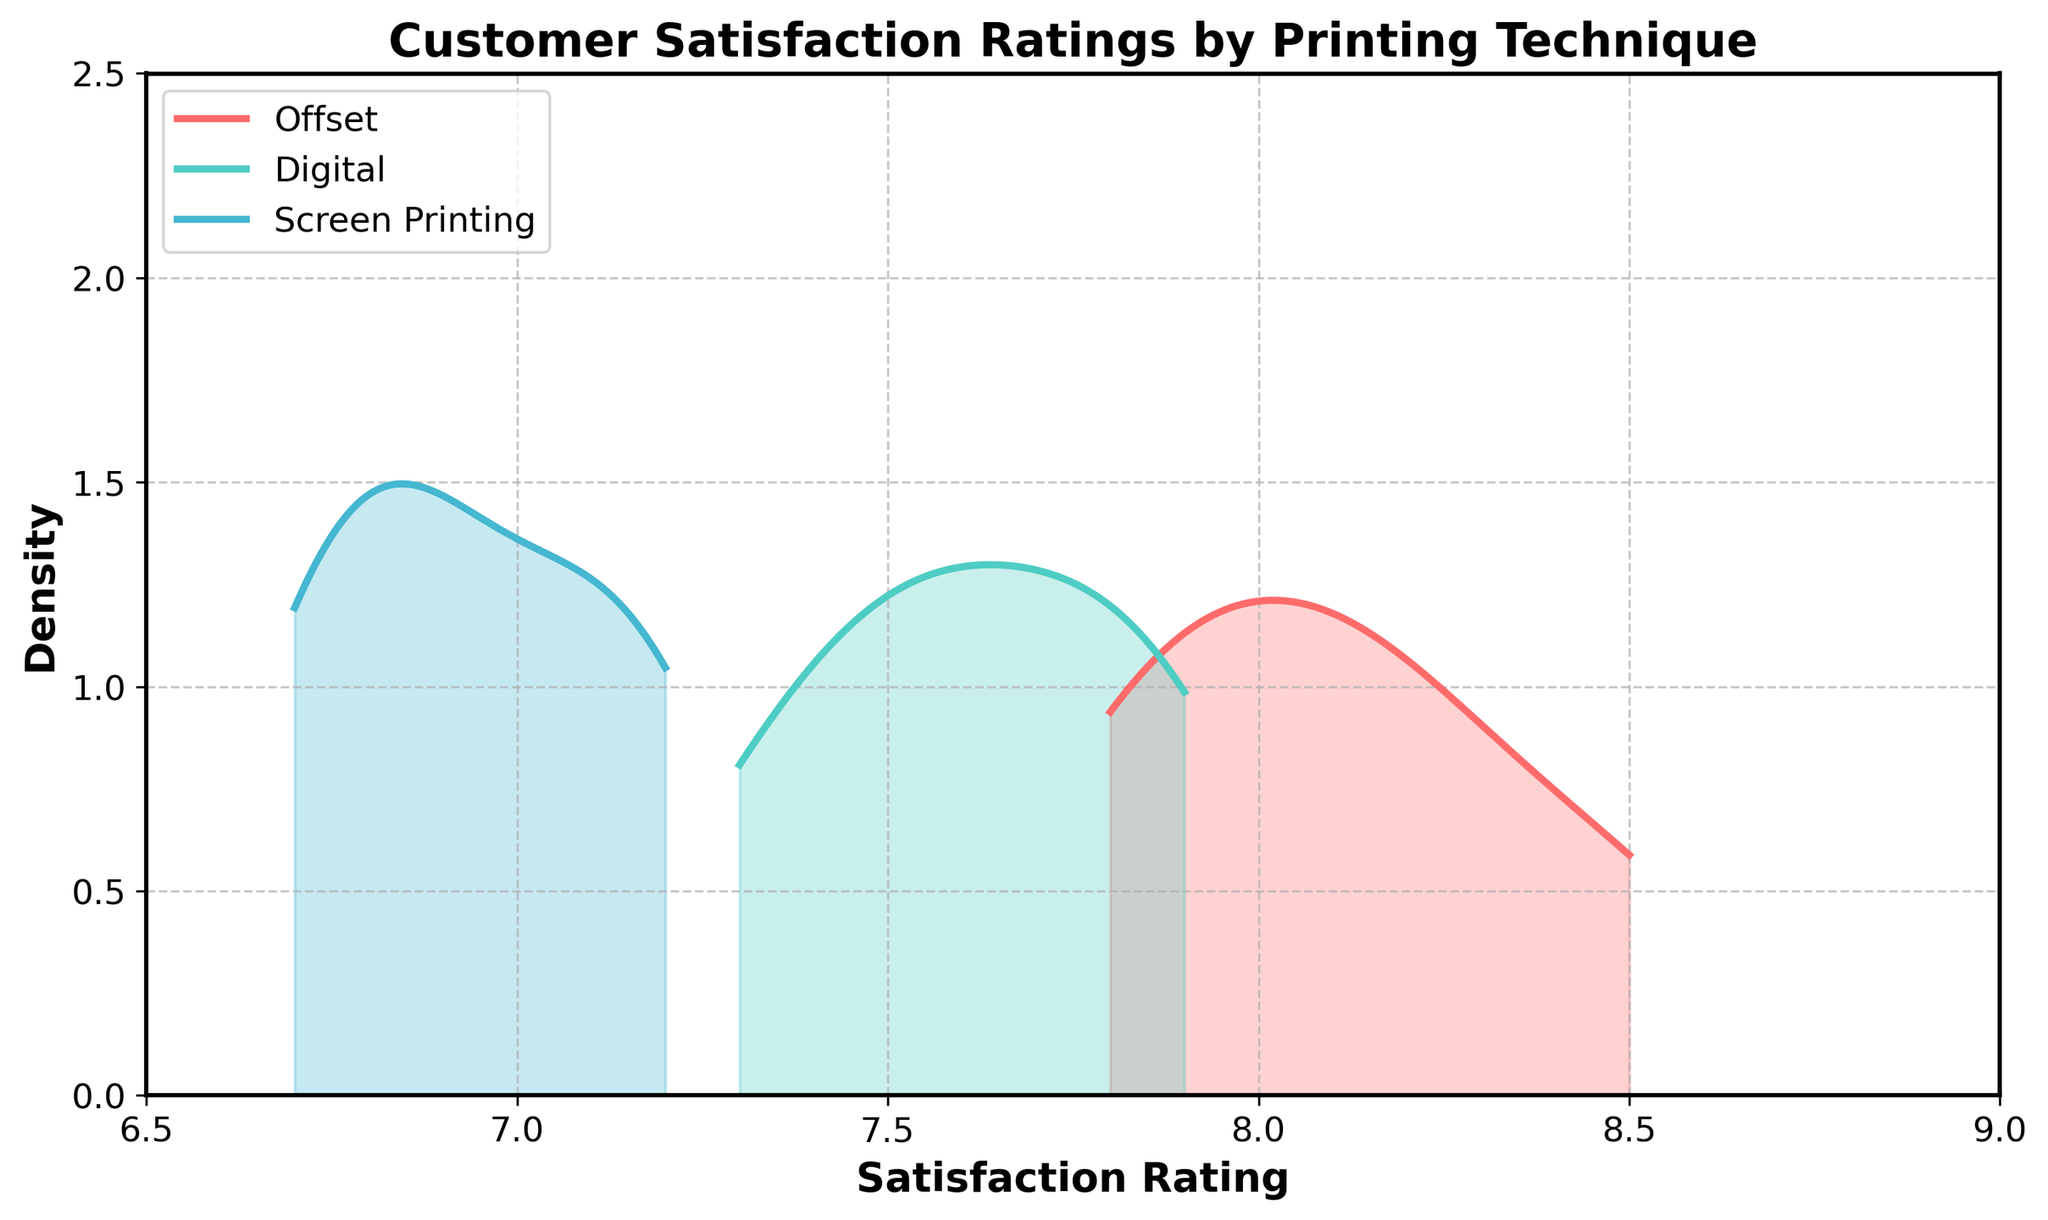What is the title of the plot? The title is located at the top of the plot, and it summarizes what the plot is about.
Answer: Customer Satisfaction Ratings by Printing Technique What are the printing techniques compared in the plot? The legend at the top left of the plot lists the printing techniques compared.
Answer: Offset, Digital, Screen Printing In terms of satisfaction ratings, which printing technique has the highest peak density? Identify the line with the highest peak and associate it with the corresponding printing technique.
Answer: Offset Which printing technique shows the most spread in satisfaction ratings according to the plot? Observe the width of the density curves: a wider spread indicates a greater range of satisfaction ratings.
Answer: Digital What is the approximate satisfaction rating range for Screen Printing? Look at the x-axis and note where the density curve for Screen Printing starts and ends.
Answer: 6.7 to 7.2 Compare the peak densities of Offset and Digital printing techniques. Which one is higher? Compare the highest points of both density curves directly.
Answer: Offset Are there any overlaps between the satisfaction rating ranges of Digital and Screen Printing techniques? Look for areas where the density curves for Digital and Screen Printing overlap on the x-axis.
Answer: Yes Which technique has its peak density closest to an 8 satisfaction rating? Find the density peak that is nearest to the x-axis value 8.
Answer: Offset What is the range of satisfaction ratings for Offset printing? Identify the minimum and maximum x-axis values for the Offset density curve.
Answer: 7.8 to 8.5 Does the Screen Printing technique have any density values greater than 2? Check the y-axis values for the Screen Printing curve to see if they exceed 2.
Answer: No 